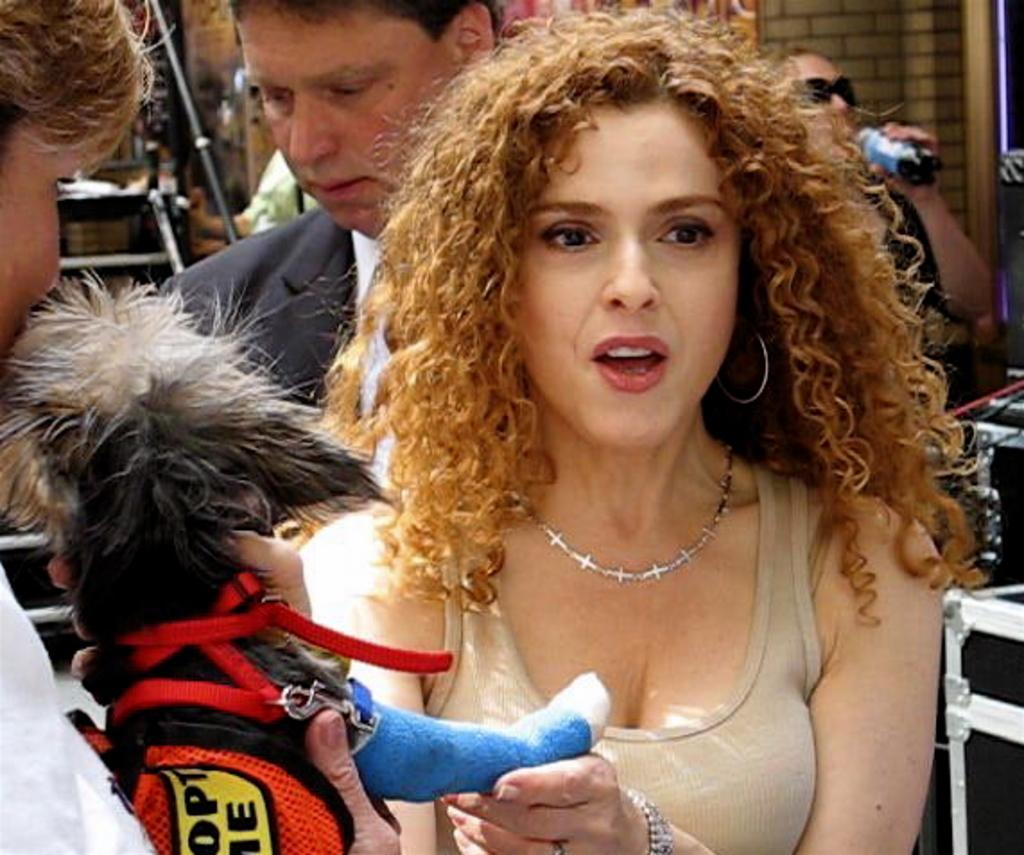Who is the main subject in the image? There is a woman in the image. What is the woman holding in the image? The woman is holding a dog. Can you describe the background of the image? There are persons and a wall in the background of the image. What type of parent is the scarecrow in the image? There is no scarecrow present in the image, so it is not possible to determine the type of parent it might be. 